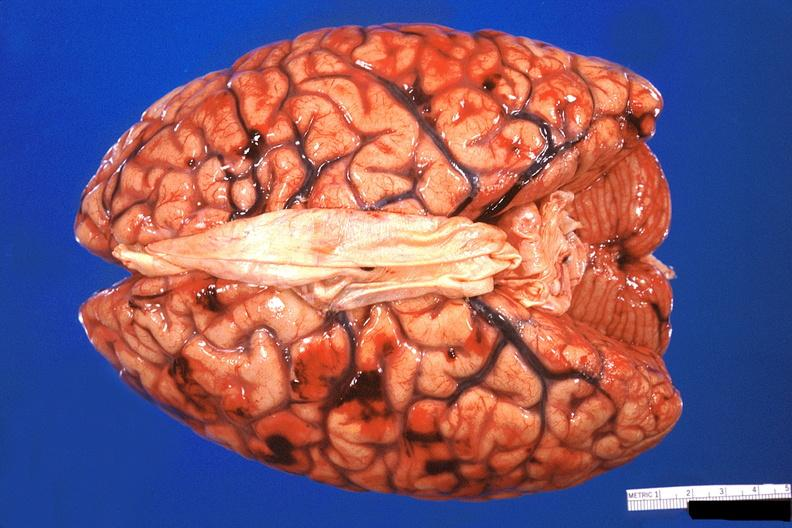why does this image show brain, subarachanoid hemorrhage?
Answer the question using a single word or phrase. Due to disseminated intravascular coagulation 